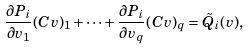Convert formula to latex. <formula><loc_0><loc_0><loc_500><loc_500>\frac { \partial P _ { i } } { \partial v _ { 1 } } ( C v ) _ { 1 } + \cdots + \frac { \partial P _ { i } } { \partial v _ { q } } ( C v ) _ { q } = \tilde { Q } _ { i } ( v ) ,</formula> 